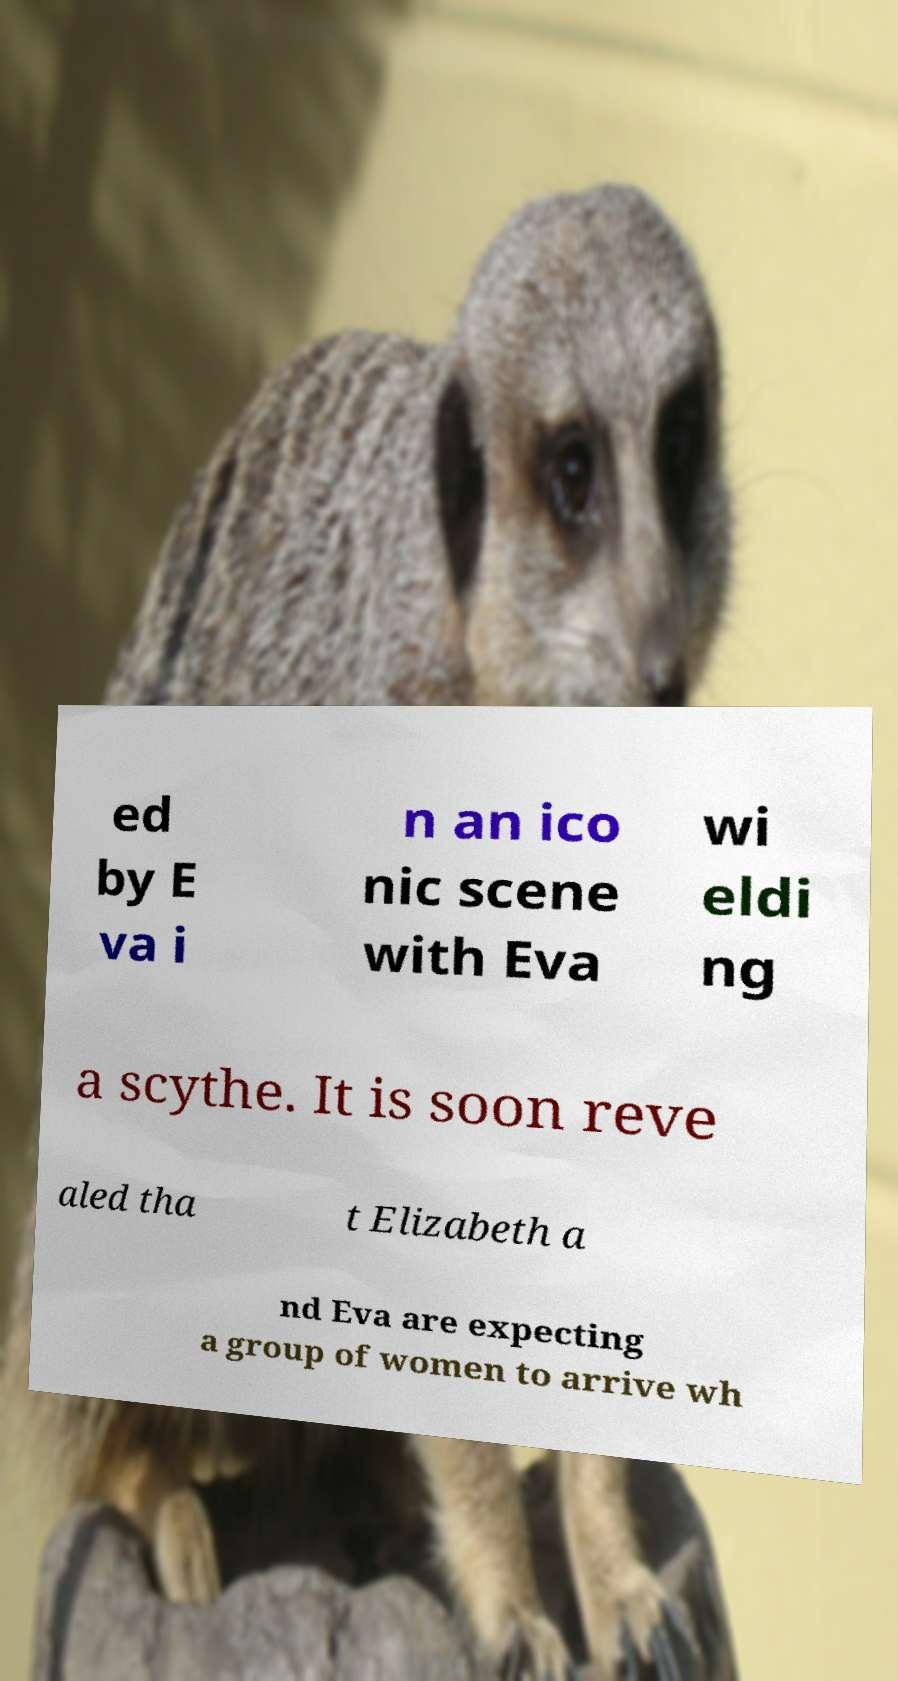Could you assist in decoding the text presented in this image and type it out clearly? ed by E va i n an ico nic scene with Eva wi eldi ng a scythe. It is soon reve aled tha t Elizabeth a nd Eva are expecting a group of women to arrive wh 